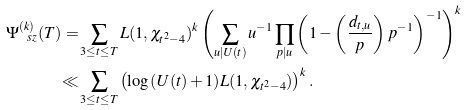<formula> <loc_0><loc_0><loc_500><loc_500>\Psi _ { \ s z } ^ { ( k ) } ( T ) = & \sum _ { 3 \leq t \leq T } L ( 1 , \chi _ { t ^ { 2 } - 4 } ) ^ { k } \left ( \sum _ { u | U ( t ) } u ^ { - 1 } \prod _ { p | u } \left ( 1 - \left ( \frac { d _ { t , u } } { p } \right ) p ^ { - 1 } \right ) ^ { - 1 } \right ) ^ { k } \\ \ll & \sum _ { 3 \leq t \leq T } \left ( \log { \left ( U ( t ) + 1 \right ) } L ( 1 , \chi _ { t ^ { 2 } - 4 } ) \right ) ^ { k } .</formula> 